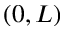Convert formula to latex. <formula><loc_0><loc_0><loc_500><loc_500>( 0 , L )</formula> 